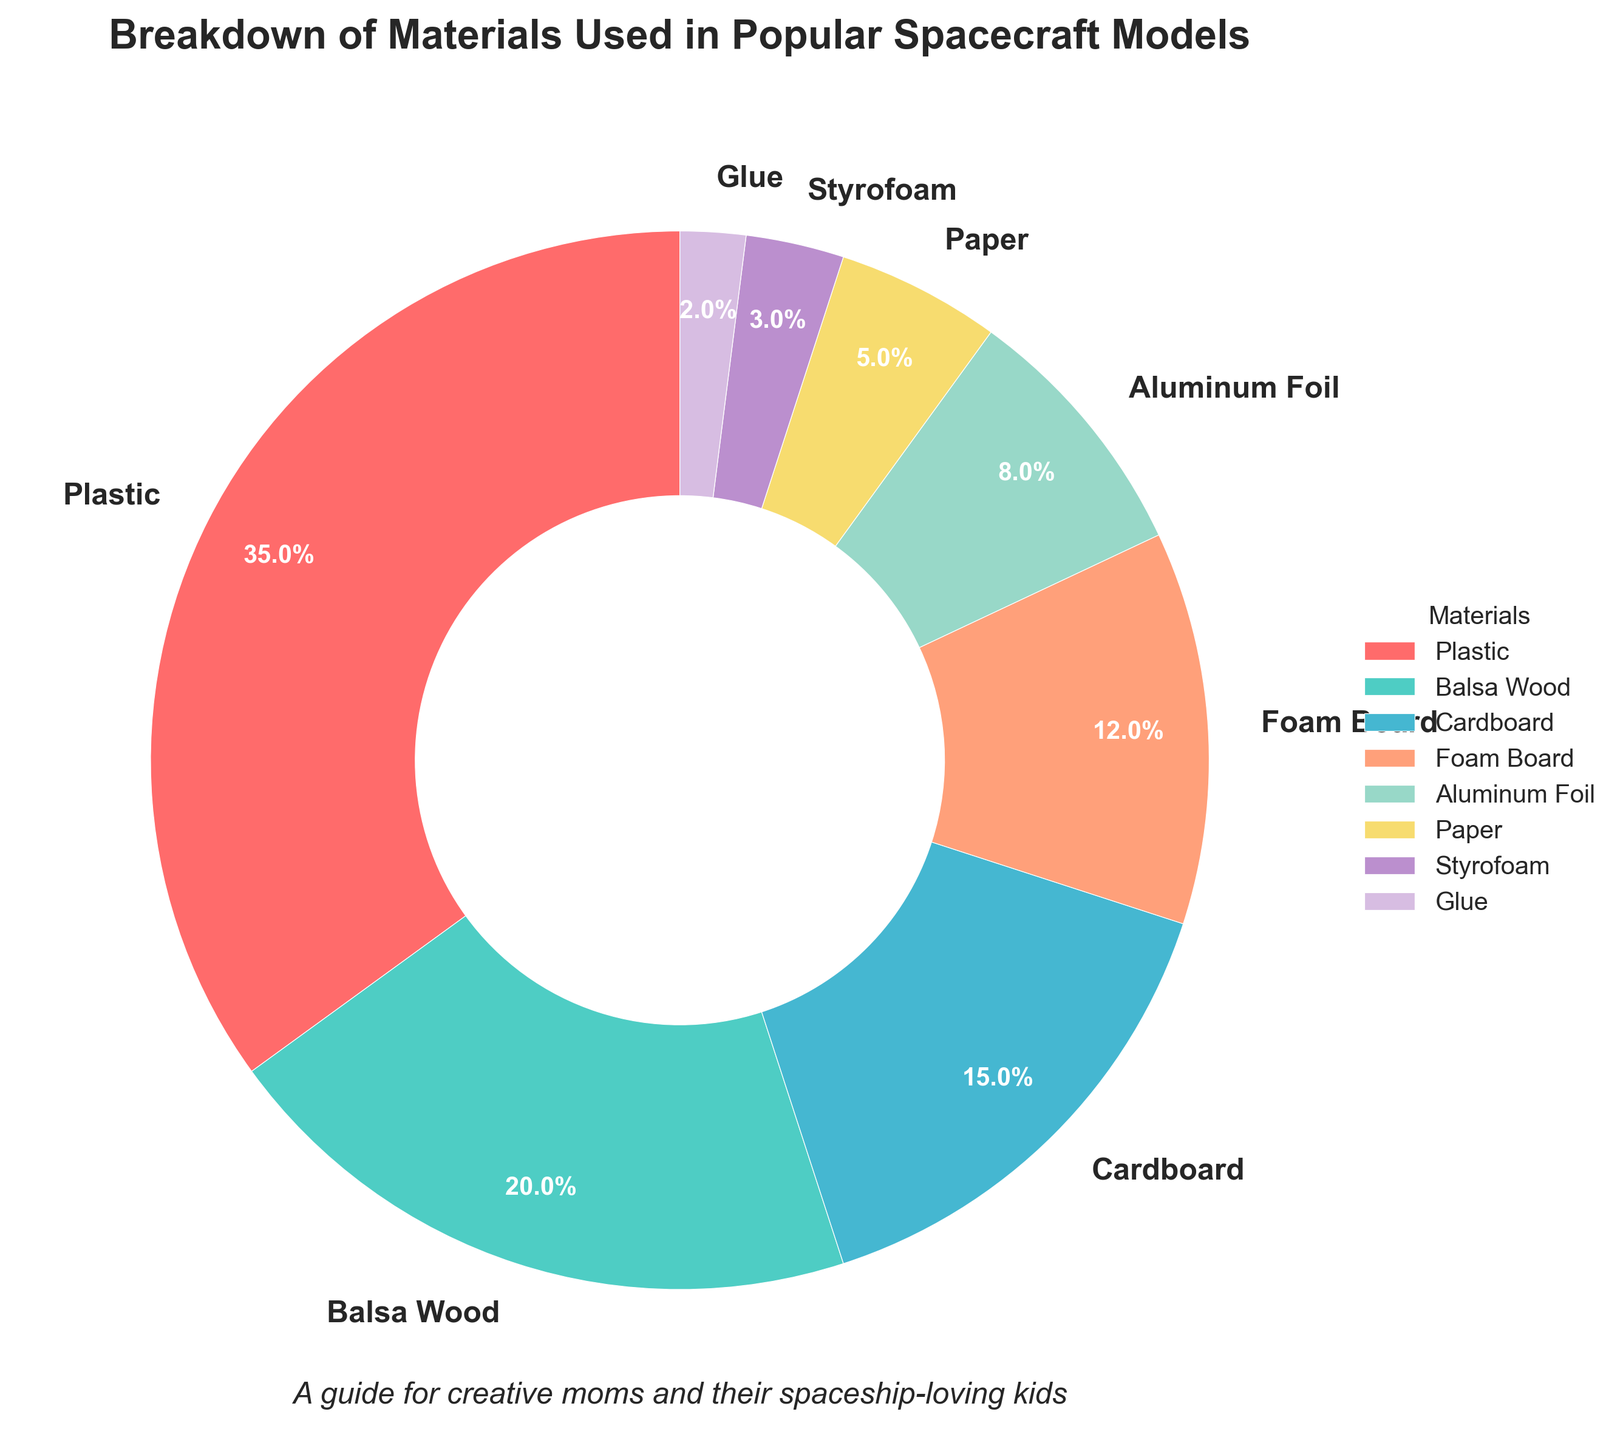what is the most used material in popular spacecraft models? The largest segment of the pie chart is labeled as "Plastic," which also has the highest percentage of 35%. Therefore, Plastic is the most used material.
Answer: Plastic What is the combined percentage of Cardboard and Foam Board? On the pie chart, Cardboard accounts for 15% and Foam Board accounts for 12%. Adding these two percentages, we get 15% + 12% = 27%.
Answer: 27% Which material is used more, Styrofoam or Aluminum Foil? According to the pie chart, Styrofoam is used in 3% of the models, whereas Aluminum Foil is used in 8% of the models. Therefore, Aluminum Foil is used more than Styrofoam.
Answer: Aluminum Foil What is the least used material and its percentage? The smallest segment of the pie chart is labeled as "Glue," which has the smallest percentage of 2%. Therefore, Glue is the least used material.
Answer: Glue Between Plastic and Balsa Wood, which material covers a larger portion of the pie chart and by how much? The pie chart shows that Plastic accounts for 35% and Balsa Wood accounts for 20%. The difference between them is 35% - 20% = 15%. Therefore, Plastic covers a larger portion by 15%.
Answer: Plastic by 15% What is the percentage of materials used other than Plastic and Balsa Wood combined? Plastic is 35% and Balsa Wood is 20%. The total percentage without these materials is 100% - 35% - 20% = 45%.
Answer: 45% Which two materials together make up nearly half of the total materials used? Plastic (35%) and Balsa Wood (20%) combined make up 35% + 20% = 55%, which is more than half. Therefore, we should look for another combination. Cardboard (15%) and Foam Board (12%) together comprise 15% + 12% = 27%, not nearly half. Looking again, no two materials exactly combine to 50%, but Plastic (35%) and Foam Board (12%) combined make 35% + 12% = 47%, which is close to half.
Answer: Plastic and Foam Board How many materials account for a usage percentage of less than 10% each, and what are they? The pie chart shows that Aluminum Foil, Paper, Styrofoam, and Glue have usage percentages of 8%, 5%, 3%, and 2% respectively, all of which are less than 10%. Therefore, there are four materials: Aluminum Foil, Paper, Styrofoam, and Glue.
Answer: Four: Aluminum Foil, Paper, Styrofoam, and Glue If you group together all materials used in less than 5% of the models, what is their total percentage? The materials used in less than 5% according to the pie chart are Styrofoam (3%) and Glue (2%). Adding these two gives 3% + 2% = 5%.
Answer: 5% Do Cardboard and Paper combined have a greater percentage than Balsa Wood? Cardboard has a percentage of 15% and Paper has 5%. Adding them gives us 15% + 5% = 20%. Balsa Wood also has a percentage of 20%. Since 20% equals 20%, they have the same percentage.
Answer: No, they are equal 